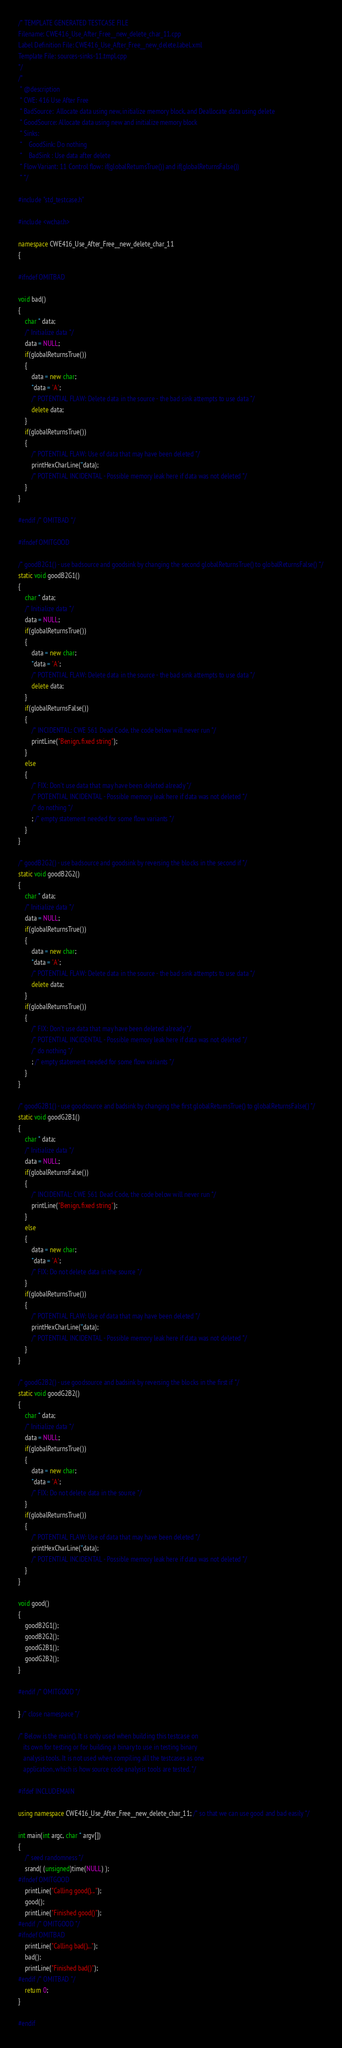<code> <loc_0><loc_0><loc_500><loc_500><_C++_>/* TEMPLATE GENERATED TESTCASE FILE
Filename: CWE416_Use_After_Free__new_delete_char_11.cpp
Label Definition File: CWE416_Use_After_Free__new_delete.label.xml
Template File: sources-sinks-11.tmpl.cpp
*/
/*
 * @description
 * CWE: 416 Use After Free
 * BadSource:  Allocate data using new, initialize memory block, and Deallocate data using delete
 * GoodSource: Allocate data using new and initialize memory block
 * Sinks:
 *    GoodSink: Do nothing
 *    BadSink : Use data after delete
 * Flow Variant: 11 Control flow: if(globalReturnsTrue()) and if(globalReturnsFalse())
 * */

#include "std_testcase.h"

#include <wchar.h>

namespace CWE416_Use_After_Free__new_delete_char_11
{

#ifndef OMITBAD

void bad()
{
    char * data;
    /* Initialize data */
    data = NULL;
    if(globalReturnsTrue())
    {
        data = new char;
        *data = 'A';
        /* POTENTIAL FLAW: Delete data in the source - the bad sink attempts to use data */
        delete data;
    }
    if(globalReturnsTrue())
    {
        /* POTENTIAL FLAW: Use of data that may have been deleted */
        printHexCharLine(*data);
        /* POTENTIAL INCIDENTAL - Possible memory leak here if data was not deleted */
    }
}

#endif /* OMITBAD */

#ifndef OMITGOOD

/* goodB2G1() - use badsource and goodsink by changing the second globalReturnsTrue() to globalReturnsFalse() */
static void goodB2G1()
{
    char * data;
    /* Initialize data */
    data = NULL;
    if(globalReturnsTrue())
    {
        data = new char;
        *data = 'A';
        /* POTENTIAL FLAW: Delete data in the source - the bad sink attempts to use data */
        delete data;
    }
    if(globalReturnsFalse())
    {
        /* INCIDENTAL: CWE 561 Dead Code, the code below will never run */
        printLine("Benign, fixed string");
    }
    else
    {
        /* FIX: Don't use data that may have been deleted already */
        /* POTENTIAL INCIDENTAL - Possible memory leak here if data was not deleted */
        /* do nothing */
        ; /* empty statement needed for some flow variants */
    }
}

/* goodB2G2() - use badsource and goodsink by reversing the blocks in the second if */
static void goodB2G2()
{
    char * data;
    /* Initialize data */
    data = NULL;
    if(globalReturnsTrue())
    {
        data = new char;
        *data = 'A';
        /* POTENTIAL FLAW: Delete data in the source - the bad sink attempts to use data */
        delete data;
    }
    if(globalReturnsTrue())
    {
        /* FIX: Don't use data that may have been deleted already */
        /* POTENTIAL INCIDENTAL - Possible memory leak here if data was not deleted */
        /* do nothing */
        ; /* empty statement needed for some flow variants */
    }
}

/* goodG2B1() - use goodsource and badsink by changing the first globalReturnsTrue() to globalReturnsFalse() */
static void goodG2B1()
{
    char * data;
    /* Initialize data */
    data = NULL;
    if(globalReturnsFalse())
    {
        /* INCIDENTAL: CWE 561 Dead Code, the code below will never run */
        printLine("Benign, fixed string");
    }
    else
    {
        data = new char;
        *data = 'A';
        /* FIX: Do not delete data in the source */
    }
    if(globalReturnsTrue())
    {
        /* POTENTIAL FLAW: Use of data that may have been deleted */
        printHexCharLine(*data);
        /* POTENTIAL INCIDENTAL - Possible memory leak here if data was not deleted */
    }
}

/* goodG2B2() - use goodsource and badsink by reversing the blocks in the first if */
static void goodG2B2()
{
    char * data;
    /* Initialize data */
    data = NULL;
    if(globalReturnsTrue())
    {
        data = new char;
        *data = 'A';
        /* FIX: Do not delete data in the source */
    }
    if(globalReturnsTrue())
    {
        /* POTENTIAL FLAW: Use of data that may have been deleted */
        printHexCharLine(*data);
        /* POTENTIAL INCIDENTAL - Possible memory leak here if data was not deleted */
    }
}

void good()
{
    goodB2G1();
    goodB2G2();
    goodG2B1();
    goodG2B2();
}

#endif /* OMITGOOD */

} /* close namespace */

/* Below is the main(). It is only used when building this testcase on
   its own for testing or for building a binary to use in testing binary
   analysis tools. It is not used when compiling all the testcases as one
   application, which is how source code analysis tools are tested. */

#ifdef INCLUDEMAIN

using namespace CWE416_Use_After_Free__new_delete_char_11; /* so that we can use good and bad easily */

int main(int argc, char * argv[])
{
    /* seed randomness */
    srand( (unsigned)time(NULL) );
#ifndef OMITGOOD
    printLine("Calling good()...");
    good();
    printLine("Finished good()");
#endif /* OMITGOOD */
#ifndef OMITBAD
    printLine("Calling bad()...");
    bad();
    printLine("Finished bad()");
#endif /* OMITBAD */
    return 0;
}

#endif
</code> 